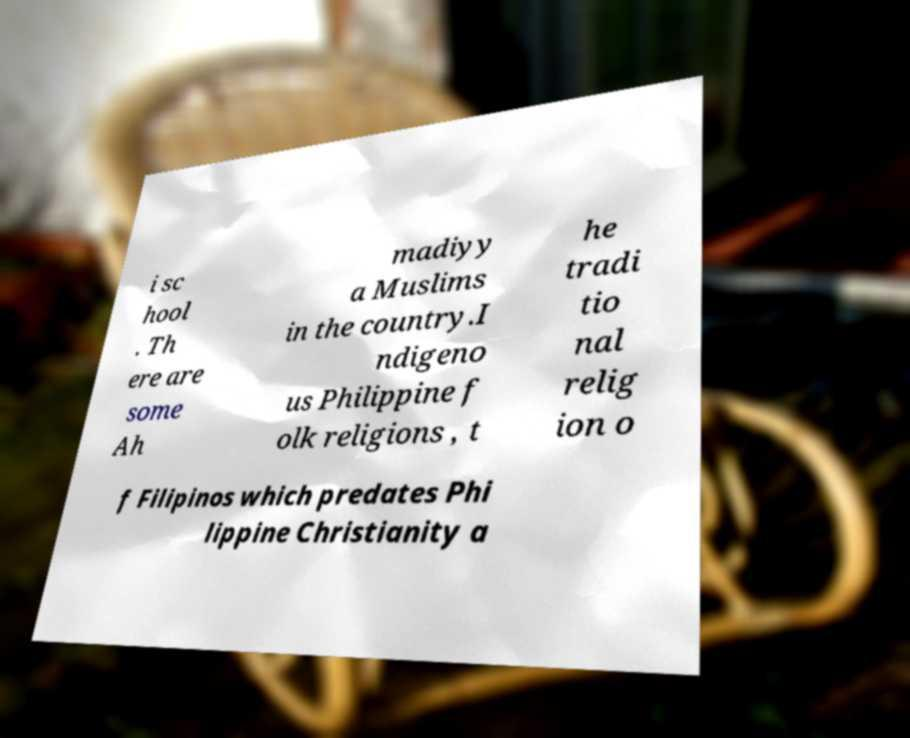What messages or text are displayed in this image? I need them in a readable, typed format. i sc hool . Th ere are some Ah madiyy a Muslims in the country.I ndigeno us Philippine f olk religions , t he tradi tio nal relig ion o f Filipinos which predates Phi lippine Christianity a 